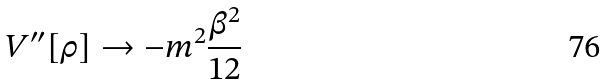<formula> <loc_0><loc_0><loc_500><loc_500>V ^ { \prime \prime } [ \rho ] \rightarrow - m ^ { 2 } \frac { \beta ^ { 2 } } { 1 2 }</formula> 